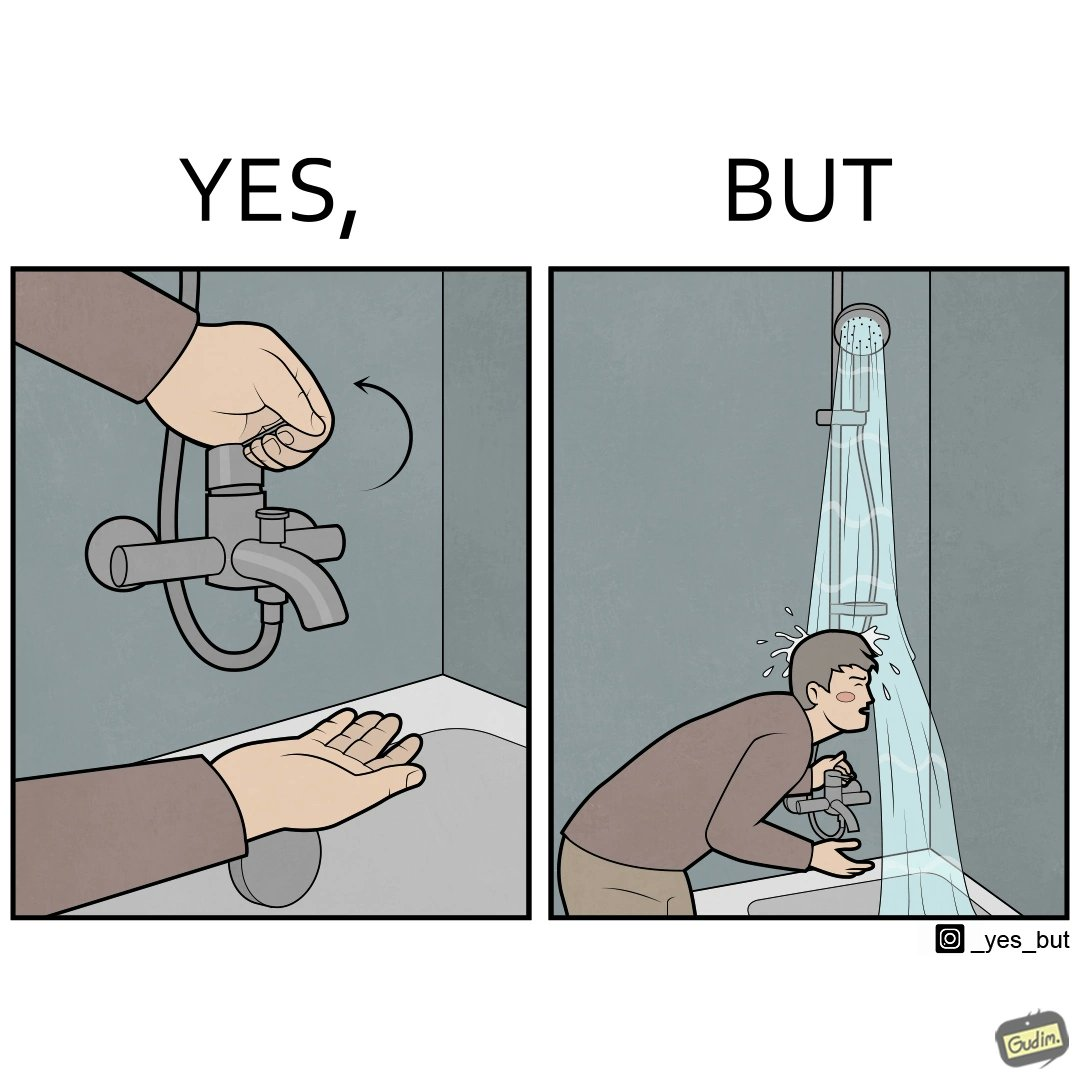Describe what you see in this image. The image is funny, as the person is trying to operate the tap, but water comes out of the handheld shower resting on a holder instead of the tap, making the person drenched in water. 